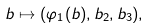<formula> <loc_0><loc_0><loc_500><loc_500>b \mapsto ( \varphi _ { 1 } ( b ) , b _ { 2 } , b _ { 3 } ) ,</formula> 